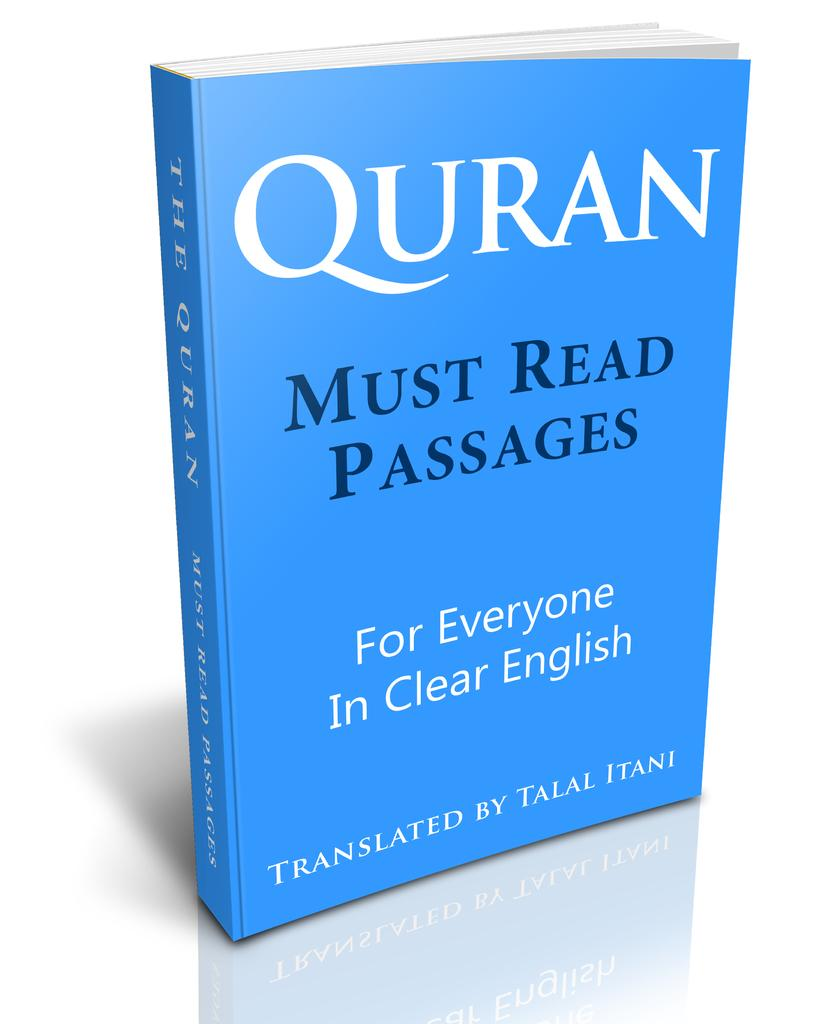<image>
Write a terse but informative summary of the picture. A blue cover of the book, :Quran, Must Read Passages." 